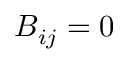<formula> <loc_0><loc_0><loc_500><loc_500>B _ { i j } = 0</formula> 